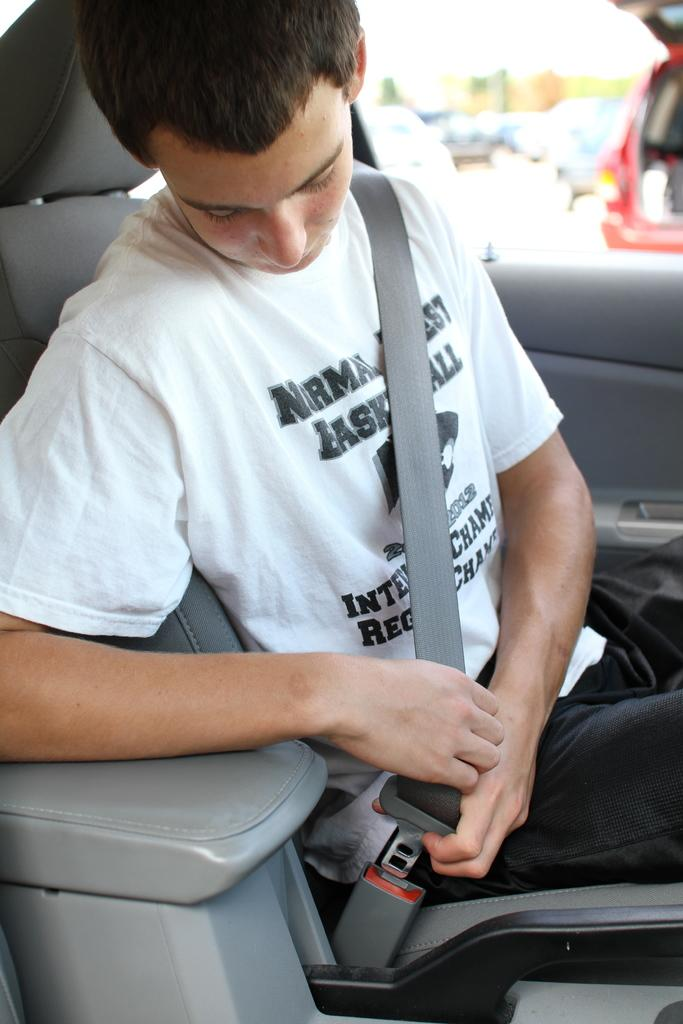What is the man in the image doing? The man is sitting in the car. What is the man wearing in the image? The man is wearing a white shirt. Is the man wearing a safety device in the image? Yes, the man is wearing a seat belt. What can be found inside the car in the image? There is a door and a seat in the car. What can be seen outside the car in the image? There is a red car visible in the right corner outside the car. How does the man's growth rate compare to the growth rate of the car in the image? There is no information about the man's growth rate or the car's growth rate in the image, so it cannot be compared. 